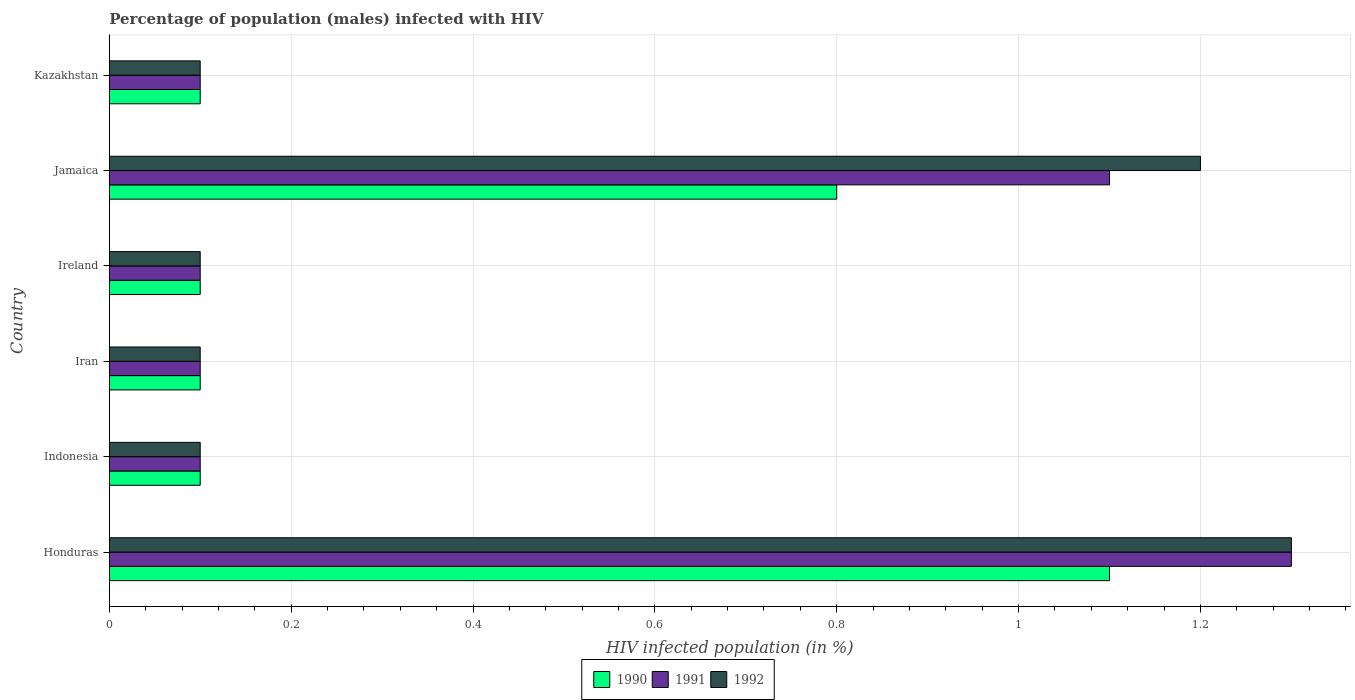How many groups of bars are there?
Give a very brief answer. 6. Are the number of bars per tick equal to the number of legend labels?
Give a very brief answer. Yes. How many bars are there on the 6th tick from the bottom?
Provide a succinct answer. 3. What is the label of the 2nd group of bars from the top?
Offer a terse response. Jamaica. What is the percentage of HIV infected male population in 1991 in Iran?
Make the answer very short. 0.1. In which country was the percentage of HIV infected male population in 1992 maximum?
Offer a very short reply. Honduras. What is the total percentage of HIV infected male population in 1990 in the graph?
Offer a terse response. 2.3. What is the difference between the percentage of HIV infected male population in 1992 in Honduras and the percentage of HIV infected male population in 1991 in Indonesia?
Keep it short and to the point. 1.2. What is the average percentage of HIV infected male population in 1992 per country?
Provide a short and direct response. 0.48. What is the difference between the percentage of HIV infected male population in 1990 and percentage of HIV infected male population in 1991 in Iran?
Give a very brief answer. 0. In how many countries, is the percentage of HIV infected male population in 1990 greater than 0.12 %?
Provide a succinct answer. 2. What is the difference between the highest and the second highest percentage of HIV infected male population in 1991?
Your answer should be compact. 0.2. What is the difference between the highest and the lowest percentage of HIV infected male population in 1992?
Your answer should be compact. 1.2. In how many countries, is the percentage of HIV infected male population in 1990 greater than the average percentage of HIV infected male population in 1990 taken over all countries?
Your response must be concise. 2. What does the 1st bar from the bottom in Jamaica represents?
Give a very brief answer. 1990. What is the difference between two consecutive major ticks on the X-axis?
Keep it short and to the point. 0.2. Are the values on the major ticks of X-axis written in scientific E-notation?
Offer a very short reply. No. Does the graph contain grids?
Provide a succinct answer. Yes. Where does the legend appear in the graph?
Keep it short and to the point. Bottom center. How are the legend labels stacked?
Give a very brief answer. Horizontal. What is the title of the graph?
Provide a short and direct response. Percentage of population (males) infected with HIV. What is the label or title of the X-axis?
Make the answer very short. HIV infected population (in %). What is the HIV infected population (in %) in 1990 in Honduras?
Ensure brevity in your answer.  1.1. What is the HIV infected population (in %) in 1992 in Indonesia?
Your answer should be compact. 0.1. What is the HIV infected population (in %) in 1991 in Iran?
Give a very brief answer. 0.1. What is the HIV infected population (in %) in 1992 in Ireland?
Keep it short and to the point. 0.1. What is the HIV infected population (in %) in 1991 in Jamaica?
Give a very brief answer. 1.1. What is the HIV infected population (in %) of 1990 in Kazakhstan?
Provide a succinct answer. 0.1. Across all countries, what is the minimum HIV infected population (in %) of 1990?
Offer a terse response. 0.1. Across all countries, what is the minimum HIV infected population (in %) in 1991?
Your answer should be very brief. 0.1. Across all countries, what is the minimum HIV infected population (in %) in 1992?
Provide a short and direct response. 0.1. What is the difference between the HIV infected population (in %) in 1992 in Honduras and that in Indonesia?
Make the answer very short. 1.2. What is the difference between the HIV infected population (in %) in 1990 in Honduras and that in Iran?
Offer a terse response. 1. What is the difference between the HIV infected population (in %) of 1991 in Honduras and that in Iran?
Ensure brevity in your answer.  1.2. What is the difference between the HIV infected population (in %) in 1992 in Honduras and that in Iran?
Provide a short and direct response. 1.2. What is the difference between the HIV infected population (in %) in 1990 in Honduras and that in Ireland?
Your answer should be very brief. 1. What is the difference between the HIV infected population (in %) in 1991 in Honduras and that in Jamaica?
Your response must be concise. 0.2. What is the difference between the HIV infected population (in %) in 1990 in Honduras and that in Kazakhstan?
Your answer should be very brief. 1. What is the difference between the HIV infected population (in %) of 1992 in Honduras and that in Kazakhstan?
Provide a short and direct response. 1.2. What is the difference between the HIV infected population (in %) of 1991 in Indonesia and that in Iran?
Make the answer very short. 0. What is the difference between the HIV infected population (in %) in 1992 in Indonesia and that in Iran?
Your answer should be very brief. 0. What is the difference between the HIV infected population (in %) in 1990 in Indonesia and that in Ireland?
Offer a terse response. 0. What is the difference between the HIV infected population (in %) in 1991 in Indonesia and that in Ireland?
Provide a succinct answer. 0. What is the difference between the HIV infected population (in %) in 1992 in Indonesia and that in Kazakhstan?
Offer a terse response. 0. What is the difference between the HIV infected population (in %) of 1990 in Iran and that in Ireland?
Offer a terse response. 0. What is the difference between the HIV infected population (in %) of 1992 in Iran and that in Kazakhstan?
Make the answer very short. 0. What is the difference between the HIV infected population (in %) of 1990 in Ireland and that in Jamaica?
Provide a short and direct response. -0.7. What is the difference between the HIV infected population (in %) of 1992 in Ireland and that in Jamaica?
Your answer should be compact. -1.1. What is the difference between the HIV infected population (in %) in 1991 in Ireland and that in Kazakhstan?
Your answer should be very brief. 0. What is the difference between the HIV infected population (in %) in 1990 in Jamaica and that in Kazakhstan?
Your answer should be compact. 0.7. What is the difference between the HIV infected population (in %) in 1991 in Jamaica and that in Kazakhstan?
Provide a succinct answer. 1. What is the difference between the HIV infected population (in %) in 1990 in Honduras and the HIV infected population (in %) in 1992 in Indonesia?
Provide a short and direct response. 1. What is the difference between the HIV infected population (in %) in 1990 in Honduras and the HIV infected population (in %) in 1992 in Ireland?
Your response must be concise. 1. What is the difference between the HIV infected population (in %) of 1991 in Honduras and the HIV infected population (in %) of 1992 in Ireland?
Make the answer very short. 1.2. What is the difference between the HIV infected population (in %) in 1990 in Honduras and the HIV infected population (in %) in 1991 in Jamaica?
Offer a terse response. 0. What is the difference between the HIV infected population (in %) in 1990 in Honduras and the HIV infected population (in %) in 1992 in Jamaica?
Offer a very short reply. -0.1. What is the difference between the HIV infected population (in %) of 1991 in Honduras and the HIV infected population (in %) of 1992 in Jamaica?
Your response must be concise. 0.1. What is the difference between the HIV infected population (in %) of 1990 in Honduras and the HIV infected population (in %) of 1991 in Kazakhstan?
Make the answer very short. 1. What is the difference between the HIV infected population (in %) of 1990 in Honduras and the HIV infected population (in %) of 1992 in Kazakhstan?
Your answer should be compact. 1. What is the difference between the HIV infected population (in %) in 1990 in Indonesia and the HIV infected population (in %) in 1992 in Iran?
Provide a succinct answer. 0. What is the difference between the HIV infected population (in %) in 1991 in Indonesia and the HIV infected population (in %) in 1992 in Iran?
Make the answer very short. 0. What is the difference between the HIV infected population (in %) of 1991 in Indonesia and the HIV infected population (in %) of 1992 in Ireland?
Offer a very short reply. 0. What is the difference between the HIV infected population (in %) of 1990 in Indonesia and the HIV infected population (in %) of 1992 in Jamaica?
Make the answer very short. -1.1. What is the difference between the HIV infected population (in %) in 1991 in Indonesia and the HIV infected population (in %) in 1992 in Jamaica?
Offer a terse response. -1.1. What is the difference between the HIV infected population (in %) in 1990 in Indonesia and the HIV infected population (in %) in 1991 in Kazakhstan?
Ensure brevity in your answer.  0. What is the difference between the HIV infected population (in %) in 1991 in Indonesia and the HIV infected population (in %) in 1992 in Kazakhstan?
Give a very brief answer. 0. What is the difference between the HIV infected population (in %) in 1990 in Iran and the HIV infected population (in %) in 1991 in Ireland?
Offer a very short reply. 0. What is the difference between the HIV infected population (in %) of 1990 in Iran and the HIV infected population (in %) of 1992 in Ireland?
Ensure brevity in your answer.  0. What is the difference between the HIV infected population (in %) of 1991 in Iran and the HIV infected population (in %) of 1992 in Ireland?
Your answer should be compact. 0. What is the difference between the HIV infected population (in %) of 1991 in Iran and the HIV infected population (in %) of 1992 in Jamaica?
Make the answer very short. -1.1. What is the difference between the HIV infected population (in %) in 1990 in Iran and the HIV infected population (in %) in 1992 in Kazakhstan?
Ensure brevity in your answer.  0. What is the difference between the HIV infected population (in %) of 1991 in Iran and the HIV infected population (in %) of 1992 in Kazakhstan?
Make the answer very short. 0. What is the difference between the HIV infected population (in %) of 1991 in Ireland and the HIV infected population (in %) of 1992 in Jamaica?
Keep it short and to the point. -1.1. What is the difference between the HIV infected population (in %) in 1990 in Ireland and the HIV infected population (in %) in 1991 in Kazakhstan?
Give a very brief answer. 0. What is the difference between the HIV infected population (in %) in 1991 in Ireland and the HIV infected population (in %) in 1992 in Kazakhstan?
Make the answer very short. 0. What is the difference between the HIV infected population (in %) of 1990 in Jamaica and the HIV infected population (in %) of 1991 in Kazakhstan?
Provide a short and direct response. 0.7. What is the difference between the HIV infected population (in %) in 1991 in Jamaica and the HIV infected population (in %) in 1992 in Kazakhstan?
Offer a terse response. 1. What is the average HIV infected population (in %) of 1990 per country?
Provide a short and direct response. 0.38. What is the average HIV infected population (in %) in 1991 per country?
Provide a short and direct response. 0.47. What is the average HIV infected population (in %) of 1992 per country?
Your answer should be compact. 0.48. What is the difference between the HIV infected population (in %) in 1990 and HIV infected population (in %) in 1992 in Honduras?
Offer a terse response. -0.2. What is the difference between the HIV infected population (in %) of 1991 and HIV infected population (in %) of 1992 in Honduras?
Your response must be concise. 0. What is the difference between the HIV infected population (in %) in 1990 and HIV infected population (in %) in 1991 in Indonesia?
Keep it short and to the point. 0. What is the difference between the HIV infected population (in %) in 1991 and HIV infected population (in %) in 1992 in Indonesia?
Your answer should be compact. 0. What is the difference between the HIV infected population (in %) in 1990 and HIV infected population (in %) in 1991 in Iran?
Offer a terse response. 0. What is the difference between the HIV infected population (in %) in 1991 and HIV infected population (in %) in 1992 in Iran?
Offer a terse response. 0. What is the difference between the HIV infected population (in %) of 1990 and HIV infected population (in %) of 1991 in Ireland?
Offer a very short reply. 0. What is the difference between the HIV infected population (in %) of 1991 and HIV infected population (in %) of 1992 in Ireland?
Offer a very short reply. 0. What is the difference between the HIV infected population (in %) in 1990 and HIV infected population (in %) in 1992 in Jamaica?
Offer a very short reply. -0.4. What is the difference between the HIV infected population (in %) of 1990 and HIV infected population (in %) of 1991 in Kazakhstan?
Offer a terse response. 0. What is the difference between the HIV infected population (in %) in 1991 and HIV infected population (in %) in 1992 in Kazakhstan?
Keep it short and to the point. 0. What is the ratio of the HIV infected population (in %) in 1990 in Honduras to that in Indonesia?
Offer a very short reply. 11. What is the ratio of the HIV infected population (in %) of 1991 in Honduras to that in Indonesia?
Ensure brevity in your answer.  13. What is the ratio of the HIV infected population (in %) of 1992 in Honduras to that in Indonesia?
Ensure brevity in your answer.  13. What is the ratio of the HIV infected population (in %) of 1991 in Honduras to that in Iran?
Offer a very short reply. 13. What is the ratio of the HIV infected population (in %) in 1990 in Honduras to that in Ireland?
Provide a short and direct response. 11. What is the ratio of the HIV infected population (in %) in 1991 in Honduras to that in Ireland?
Make the answer very short. 13. What is the ratio of the HIV infected population (in %) in 1990 in Honduras to that in Jamaica?
Provide a succinct answer. 1.38. What is the ratio of the HIV infected population (in %) in 1991 in Honduras to that in Jamaica?
Your answer should be very brief. 1.18. What is the ratio of the HIV infected population (in %) of 1992 in Honduras to that in Jamaica?
Your answer should be compact. 1.08. What is the ratio of the HIV infected population (in %) in 1991 in Honduras to that in Kazakhstan?
Your response must be concise. 13. What is the ratio of the HIV infected population (in %) in 1990 in Indonesia to that in Iran?
Your response must be concise. 1. What is the ratio of the HIV infected population (in %) in 1990 in Indonesia to that in Ireland?
Your response must be concise. 1. What is the ratio of the HIV infected population (in %) of 1991 in Indonesia to that in Ireland?
Your answer should be very brief. 1. What is the ratio of the HIV infected population (in %) of 1990 in Indonesia to that in Jamaica?
Give a very brief answer. 0.12. What is the ratio of the HIV infected population (in %) of 1991 in Indonesia to that in Jamaica?
Provide a short and direct response. 0.09. What is the ratio of the HIV infected population (in %) of 1992 in Indonesia to that in Jamaica?
Your response must be concise. 0.08. What is the ratio of the HIV infected population (in %) of 1990 in Indonesia to that in Kazakhstan?
Provide a short and direct response. 1. What is the ratio of the HIV infected population (in %) of 1991 in Iran to that in Ireland?
Your response must be concise. 1. What is the ratio of the HIV infected population (in %) in 1991 in Iran to that in Jamaica?
Ensure brevity in your answer.  0.09. What is the ratio of the HIV infected population (in %) of 1992 in Iran to that in Jamaica?
Your response must be concise. 0.08. What is the ratio of the HIV infected population (in %) in 1990 in Iran to that in Kazakhstan?
Your response must be concise. 1. What is the ratio of the HIV infected population (in %) of 1991 in Iran to that in Kazakhstan?
Offer a terse response. 1. What is the ratio of the HIV infected population (in %) of 1991 in Ireland to that in Jamaica?
Your answer should be very brief. 0.09. What is the ratio of the HIV infected population (in %) in 1992 in Ireland to that in Jamaica?
Your response must be concise. 0.08. What is the ratio of the HIV infected population (in %) of 1990 in Ireland to that in Kazakhstan?
Your answer should be compact. 1. What is the ratio of the HIV infected population (in %) in 1991 in Ireland to that in Kazakhstan?
Provide a short and direct response. 1. What is the ratio of the HIV infected population (in %) in 1991 in Jamaica to that in Kazakhstan?
Ensure brevity in your answer.  11. What is the difference between the highest and the second highest HIV infected population (in %) in 1991?
Provide a short and direct response. 0.2. What is the difference between the highest and the second highest HIV infected population (in %) of 1992?
Your response must be concise. 0.1. 